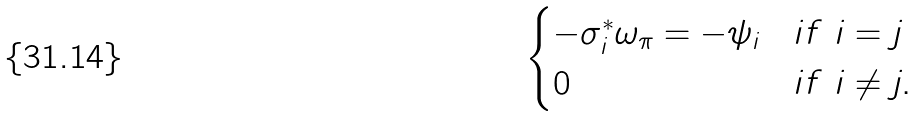<formula> <loc_0><loc_0><loc_500><loc_500>\begin{cases} - \sigma ^ { * } _ { i } \omega _ { \pi } = - \psi _ { i } & i f \ i = j \\ 0 & i f \ i \neq j . \end{cases}</formula> 